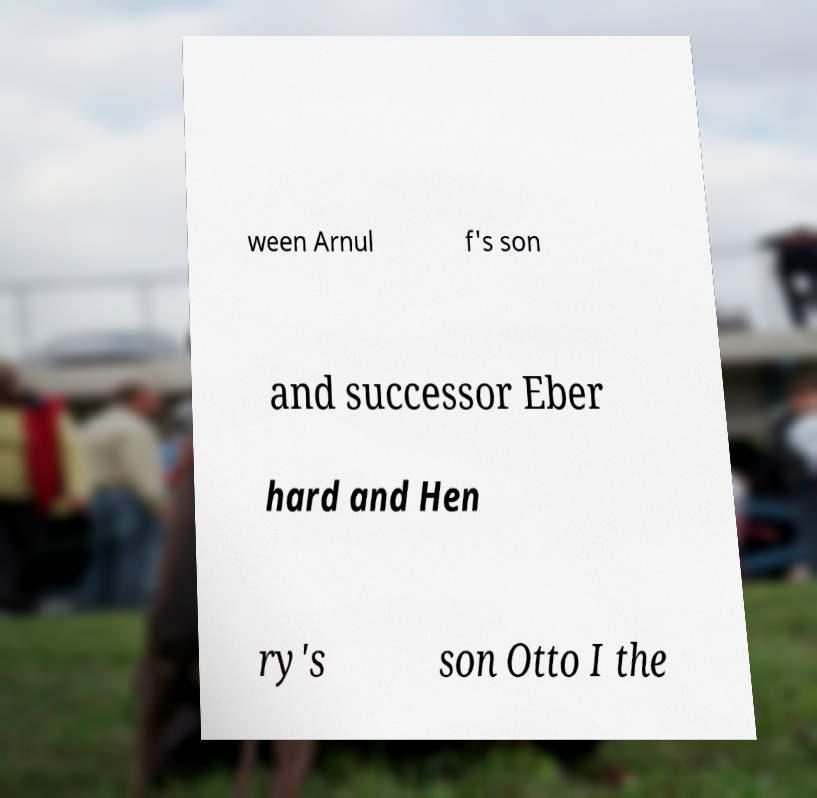Can you accurately transcribe the text from the provided image for me? ween Arnul f's son and successor Eber hard and Hen ry's son Otto I the 